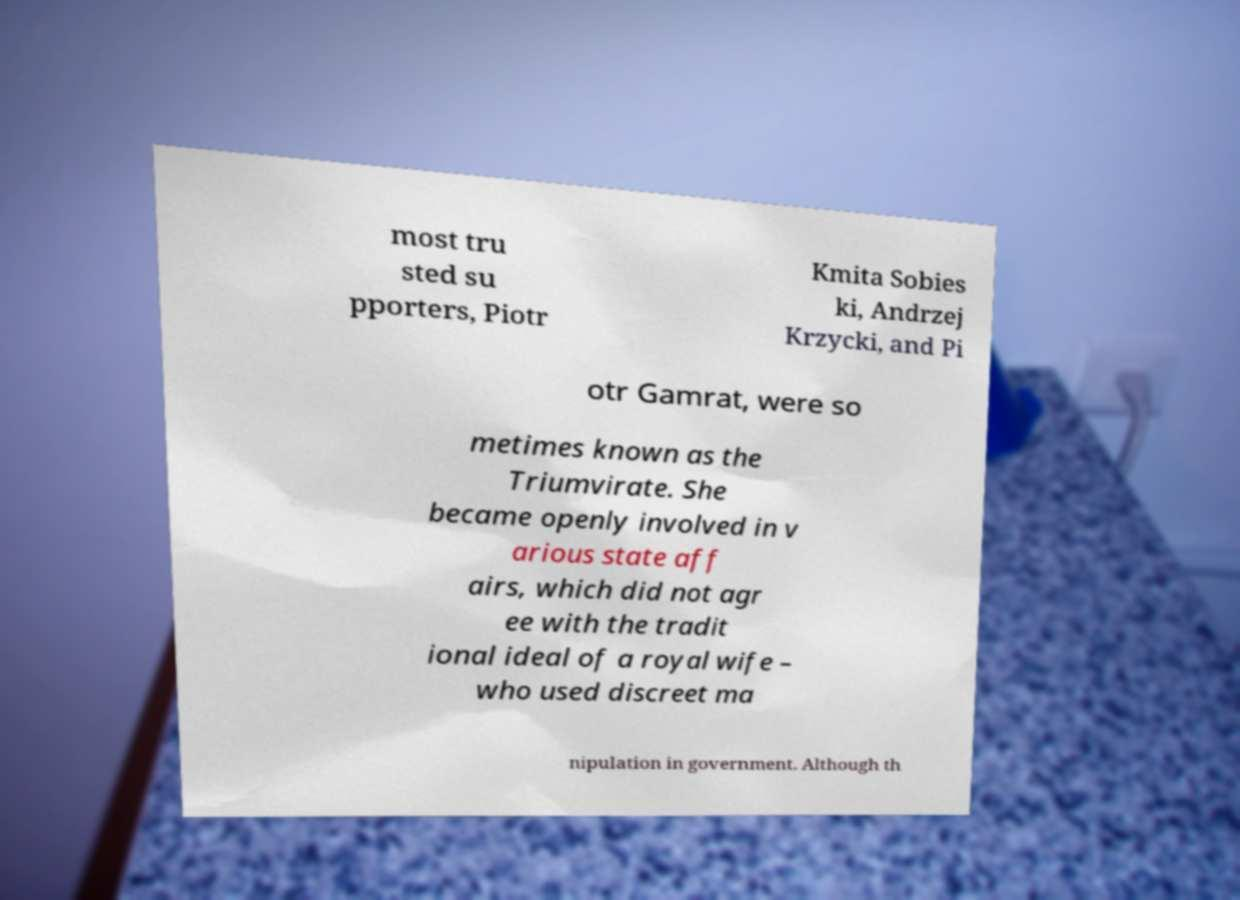For documentation purposes, I need the text within this image transcribed. Could you provide that? most tru sted su pporters, Piotr Kmita Sobies ki, Andrzej Krzycki, and Pi otr Gamrat, were so metimes known as the Triumvirate. She became openly involved in v arious state aff airs, which did not agr ee with the tradit ional ideal of a royal wife – who used discreet ma nipulation in government. Although th 